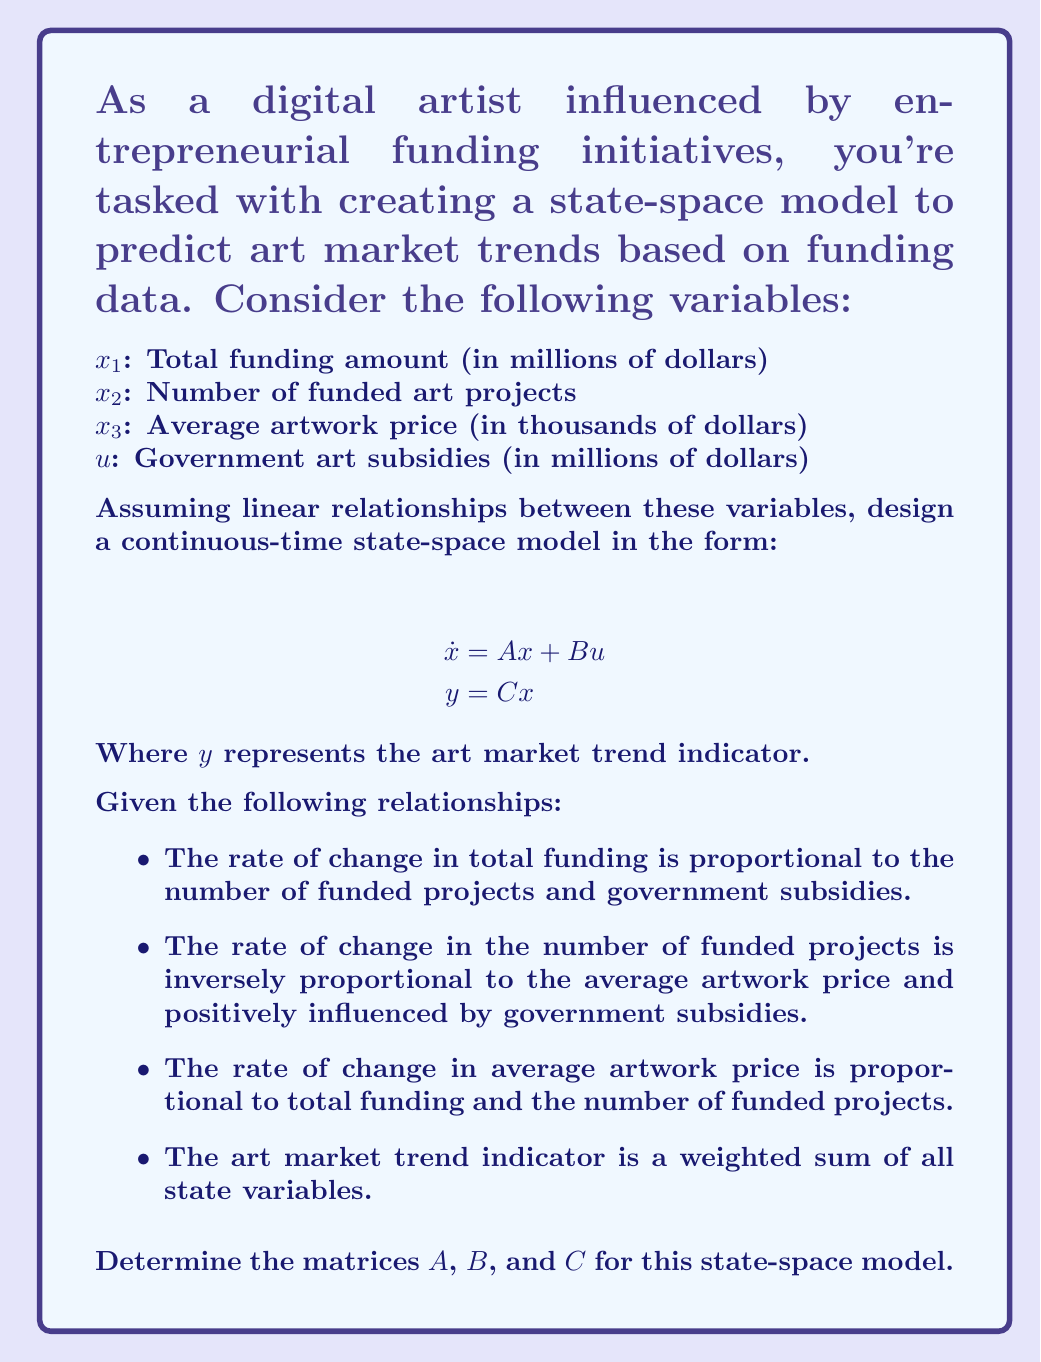Give your solution to this math problem. To design the state-space model, we need to define the $A$, $B$, and $C$ matrices based on the given relationships:

1. For matrix $A$:
   - $\dot{x}_1 = a_{12}x_2$ (proportional to number of funded projects)
   - $\dot{x}_2 = -a_{23}x_3 + a_{21}x_1$ (inversely proportional to average price, positively related to total funding)
   - $\dot{x}_3 = a_{31}x_1 + a_{32}x_2$ (proportional to total funding and number of projects)

   Therefore, matrix $A$ is:
   $$A = \begin{bmatrix}
   0 & a_{12} & 0 \\
   a_{21} & 0 & -a_{23} \\
   a_{31} & a_{32} & 0
   \end{bmatrix}$$

2. For matrix $B$:
   - $\dot{x}_1$ is influenced by $u$ (government subsidies)
   - $\dot{x}_2$ is influenced by $u$
   - $\dot{x}_3$ is not directly influenced by $u$

   Therefore, matrix $B$ is:
   $$B = \begin{bmatrix}
   b_1 \\
   b_2 \\
   0
   \end{bmatrix}$$

3. For matrix $C$:
   - $y$ is a weighted sum of all state variables

   Therefore, matrix $C$ is:
   $$C = \begin{bmatrix}
   c_1 & c_2 & c_3
   \end{bmatrix}$$

The complete state-space model is:

$$\dot{x} = \begin{bmatrix}
0 & a_{12} & 0 \\
a_{21} & 0 & -a_{23} \\
a_{31} & a_{32} & 0
\end{bmatrix}x + \begin{bmatrix}
b_1 \\
b_2 \\
0
\end{bmatrix}u$$

$$y = \begin{bmatrix}
c_1 & c_2 & c_3
\end{bmatrix}x$$

Where $a_{ij}$, $b_i$, and $c_i$ are constants that need to be determined based on historical data and expert knowledge of the art market.
Answer: $A = \begin{bmatrix}
0 & a_{12} & 0 \\
a_{21} & 0 & -a_{23} \\
a_{31} & a_{32} & 0
\end{bmatrix}$, $B = \begin{bmatrix}
b_1 \\
b_2 \\
0
\end{bmatrix}$, $C = \begin{bmatrix}
c_1 & c_2 & c_3
\end{bmatrix}$ 